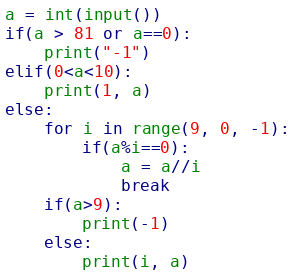Convert code to text. <code><loc_0><loc_0><loc_500><loc_500><_Python_>a = int(input())
if(a > 81 or a==0):
    print("-1")
elif(0<a<10):
    print(1, a)
else:
    for i in range(9, 0, -1):
        if(a%i==0):
            a = a//i
            break
    if(a>9):
        print(-1)
    else:
        print(i, a)</code> 